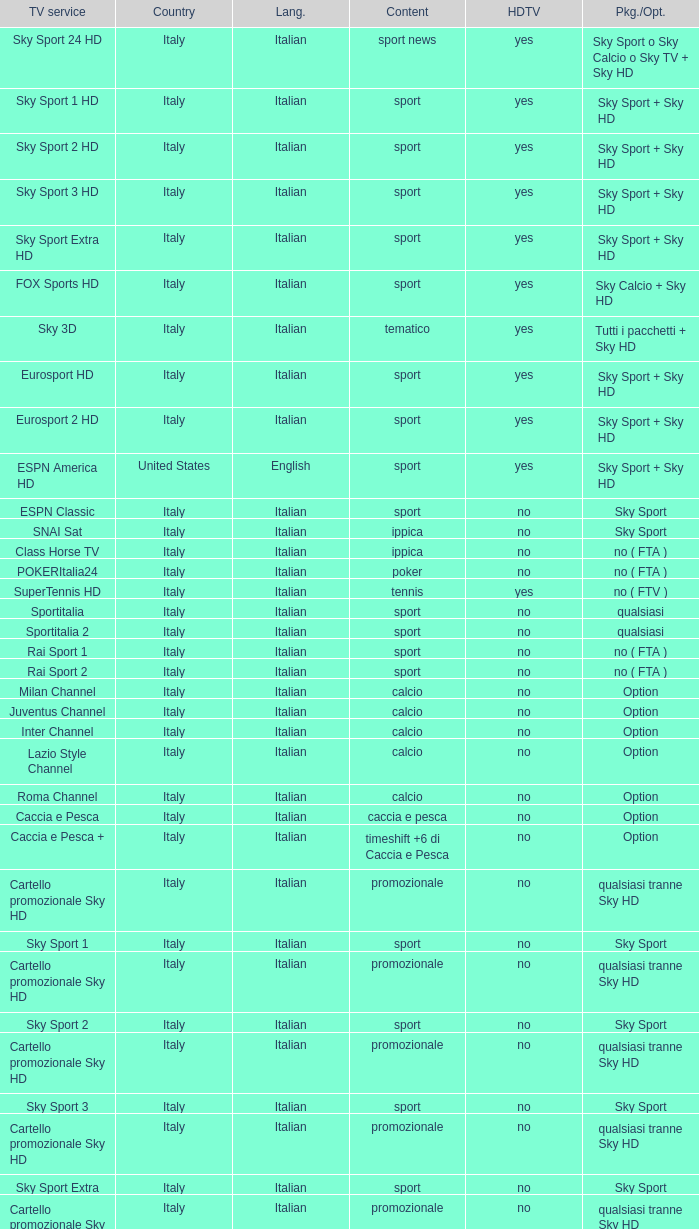What is Package/Option, when Content is Tennis? No ( ftv ). Can you parse all the data within this table? {'header': ['TV service', 'Country', 'Lang.', 'Content', 'HDTV', 'Pkg./Opt.'], 'rows': [['Sky Sport 24 HD', 'Italy', 'Italian', 'sport news', 'yes', 'Sky Sport o Sky Calcio o Sky TV + Sky HD'], ['Sky Sport 1 HD', 'Italy', 'Italian', 'sport', 'yes', 'Sky Sport + Sky HD'], ['Sky Sport 2 HD', 'Italy', 'Italian', 'sport', 'yes', 'Sky Sport + Sky HD'], ['Sky Sport 3 HD', 'Italy', 'Italian', 'sport', 'yes', 'Sky Sport + Sky HD'], ['Sky Sport Extra HD', 'Italy', 'Italian', 'sport', 'yes', 'Sky Sport + Sky HD'], ['FOX Sports HD', 'Italy', 'Italian', 'sport', 'yes', 'Sky Calcio + Sky HD'], ['Sky 3D', 'Italy', 'Italian', 'tematico', 'yes', 'Tutti i pacchetti + Sky HD'], ['Eurosport HD', 'Italy', 'Italian', 'sport', 'yes', 'Sky Sport + Sky HD'], ['Eurosport 2 HD', 'Italy', 'Italian', 'sport', 'yes', 'Sky Sport + Sky HD'], ['ESPN America HD', 'United States', 'English', 'sport', 'yes', 'Sky Sport + Sky HD'], ['ESPN Classic', 'Italy', 'Italian', 'sport', 'no', 'Sky Sport'], ['SNAI Sat', 'Italy', 'Italian', 'ippica', 'no', 'Sky Sport'], ['Class Horse TV', 'Italy', 'Italian', 'ippica', 'no', 'no ( FTA )'], ['POKERItalia24', 'Italy', 'Italian', 'poker', 'no', 'no ( FTA )'], ['SuperTennis HD', 'Italy', 'Italian', 'tennis', 'yes', 'no ( FTV )'], ['Sportitalia', 'Italy', 'Italian', 'sport', 'no', 'qualsiasi'], ['Sportitalia 2', 'Italy', 'Italian', 'sport', 'no', 'qualsiasi'], ['Rai Sport 1', 'Italy', 'Italian', 'sport', 'no', 'no ( FTA )'], ['Rai Sport 2', 'Italy', 'Italian', 'sport', 'no', 'no ( FTA )'], ['Milan Channel', 'Italy', 'Italian', 'calcio', 'no', 'Option'], ['Juventus Channel', 'Italy', 'Italian', 'calcio', 'no', 'Option'], ['Inter Channel', 'Italy', 'Italian', 'calcio', 'no', 'Option'], ['Lazio Style Channel', 'Italy', 'Italian', 'calcio', 'no', 'Option'], ['Roma Channel', 'Italy', 'Italian', 'calcio', 'no', 'Option'], ['Caccia e Pesca', 'Italy', 'Italian', 'caccia e pesca', 'no', 'Option'], ['Caccia e Pesca +', 'Italy', 'Italian', 'timeshift +6 di Caccia e Pesca', 'no', 'Option'], ['Cartello promozionale Sky HD', 'Italy', 'Italian', 'promozionale', 'no', 'qualsiasi tranne Sky HD'], ['Sky Sport 1', 'Italy', 'Italian', 'sport', 'no', 'Sky Sport'], ['Cartello promozionale Sky HD', 'Italy', 'Italian', 'promozionale', 'no', 'qualsiasi tranne Sky HD'], ['Sky Sport 2', 'Italy', 'Italian', 'sport', 'no', 'Sky Sport'], ['Cartello promozionale Sky HD', 'Italy', 'Italian', 'promozionale', 'no', 'qualsiasi tranne Sky HD'], ['Sky Sport 3', 'Italy', 'Italian', 'sport', 'no', 'Sky Sport'], ['Cartello promozionale Sky HD', 'Italy', 'Italian', 'promozionale', 'no', 'qualsiasi tranne Sky HD'], ['Sky Sport Extra', 'Italy', 'Italian', 'sport', 'no', 'Sky Sport'], ['Cartello promozionale Sky HD', 'Italy', 'Italian', 'promozionale', 'no', 'qualsiasi tranne Sky HD'], ['Sky Supercalcio', 'Italy', 'Italian', 'calcio', 'no', 'Sky Calcio'], ['Cartello promozionale Sky HD', 'Italy', 'Italian', 'promozionale', 'no', 'qualsiasi tranne Sky HD'], ['Eurosport', 'Italy', 'Italian', 'sport', 'no', 'Sky Sport'], ['Eurosport 2', 'Italy', 'Italian', 'sport', 'no', 'Sky Sport'], ['ESPN America', 'Italy', 'Italian', 'sport', 'no', 'Sky Sport']]} 